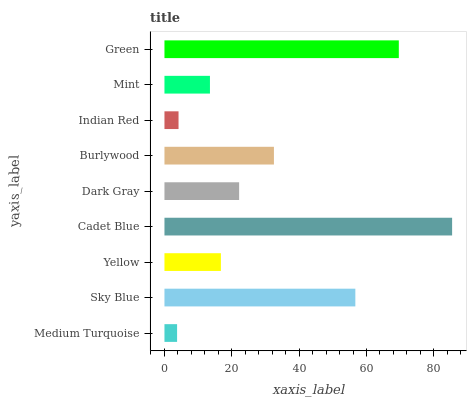Is Medium Turquoise the minimum?
Answer yes or no. Yes. Is Cadet Blue the maximum?
Answer yes or no. Yes. Is Sky Blue the minimum?
Answer yes or no. No. Is Sky Blue the maximum?
Answer yes or no. No. Is Sky Blue greater than Medium Turquoise?
Answer yes or no. Yes. Is Medium Turquoise less than Sky Blue?
Answer yes or no. Yes. Is Medium Turquoise greater than Sky Blue?
Answer yes or no. No. Is Sky Blue less than Medium Turquoise?
Answer yes or no. No. Is Dark Gray the high median?
Answer yes or no. Yes. Is Dark Gray the low median?
Answer yes or no. Yes. Is Sky Blue the high median?
Answer yes or no. No. Is Medium Turquoise the low median?
Answer yes or no. No. 